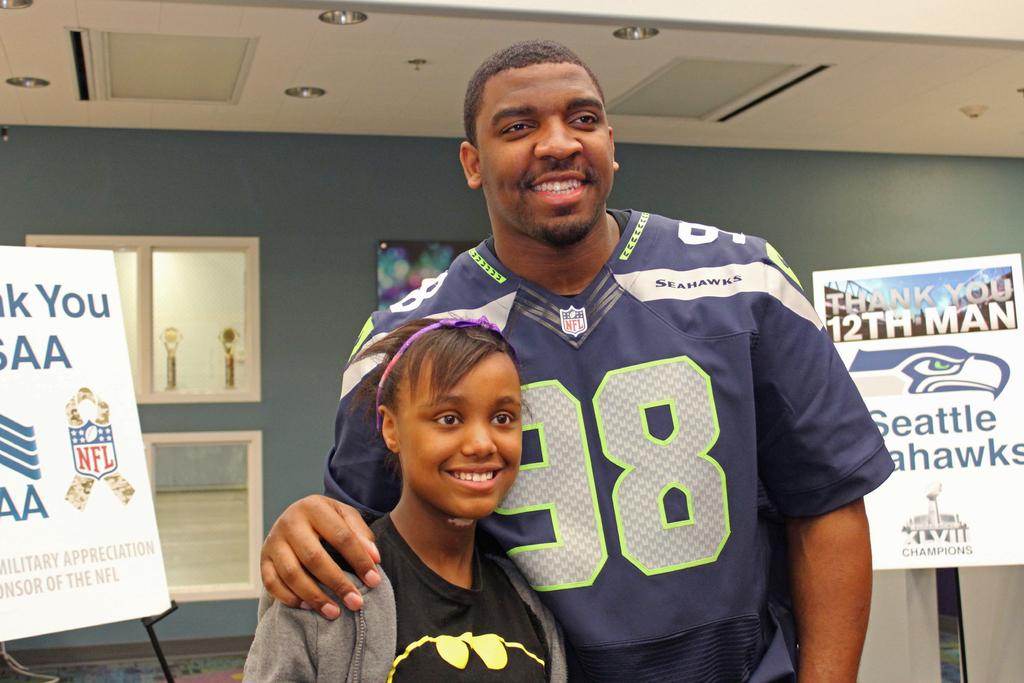What sports team is represented here?
Make the answer very short. Seattle seahawks. What national sports team logo is on the board behind the girl?
Give a very brief answer. Nfl. 